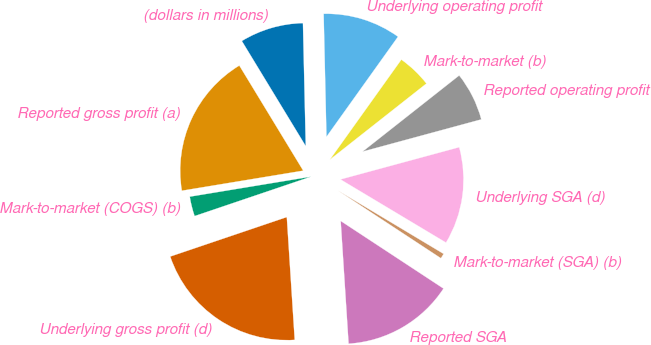Convert chart to OTSL. <chart><loc_0><loc_0><loc_500><loc_500><pie_chart><fcel>(dollars in millions)<fcel>Reported gross profit (a)<fcel>Mark-to-market (COGS) (b)<fcel>Underlying gross profit (d)<fcel>Reported SGA<fcel>Mark-to-market (SGA) (b)<fcel>Underlying SGA (d)<fcel>Reported operating profit<fcel>Mark-to-market (b)<fcel>Underlying operating profit<nl><fcel>8.33%<fcel>18.91%<fcel>2.59%<fcel>20.83%<fcel>14.72%<fcel>0.67%<fcel>12.8%<fcel>6.41%<fcel>4.5%<fcel>10.24%<nl></chart> 